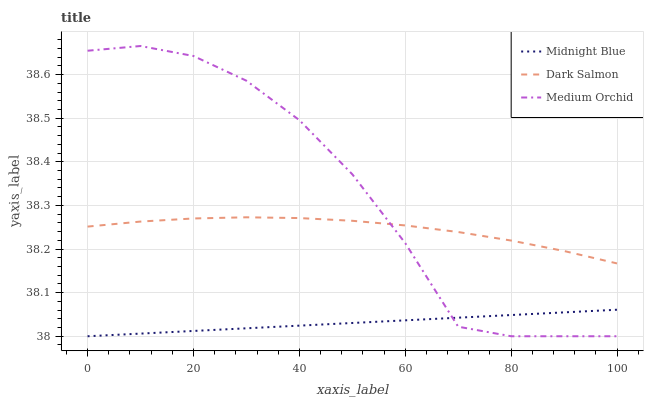Does Midnight Blue have the minimum area under the curve?
Answer yes or no. Yes. Does Medium Orchid have the maximum area under the curve?
Answer yes or no. Yes. Does Dark Salmon have the minimum area under the curve?
Answer yes or no. No. Does Dark Salmon have the maximum area under the curve?
Answer yes or no. No. Is Midnight Blue the smoothest?
Answer yes or no. Yes. Is Medium Orchid the roughest?
Answer yes or no. Yes. Is Dark Salmon the smoothest?
Answer yes or no. No. Is Dark Salmon the roughest?
Answer yes or no. No. Does Medium Orchid have the lowest value?
Answer yes or no. Yes. Does Dark Salmon have the lowest value?
Answer yes or no. No. Does Medium Orchid have the highest value?
Answer yes or no. Yes. Does Dark Salmon have the highest value?
Answer yes or no. No. Is Midnight Blue less than Dark Salmon?
Answer yes or no. Yes. Is Dark Salmon greater than Midnight Blue?
Answer yes or no. Yes. Does Medium Orchid intersect Midnight Blue?
Answer yes or no. Yes. Is Medium Orchid less than Midnight Blue?
Answer yes or no. No. Is Medium Orchid greater than Midnight Blue?
Answer yes or no. No. Does Midnight Blue intersect Dark Salmon?
Answer yes or no. No. 